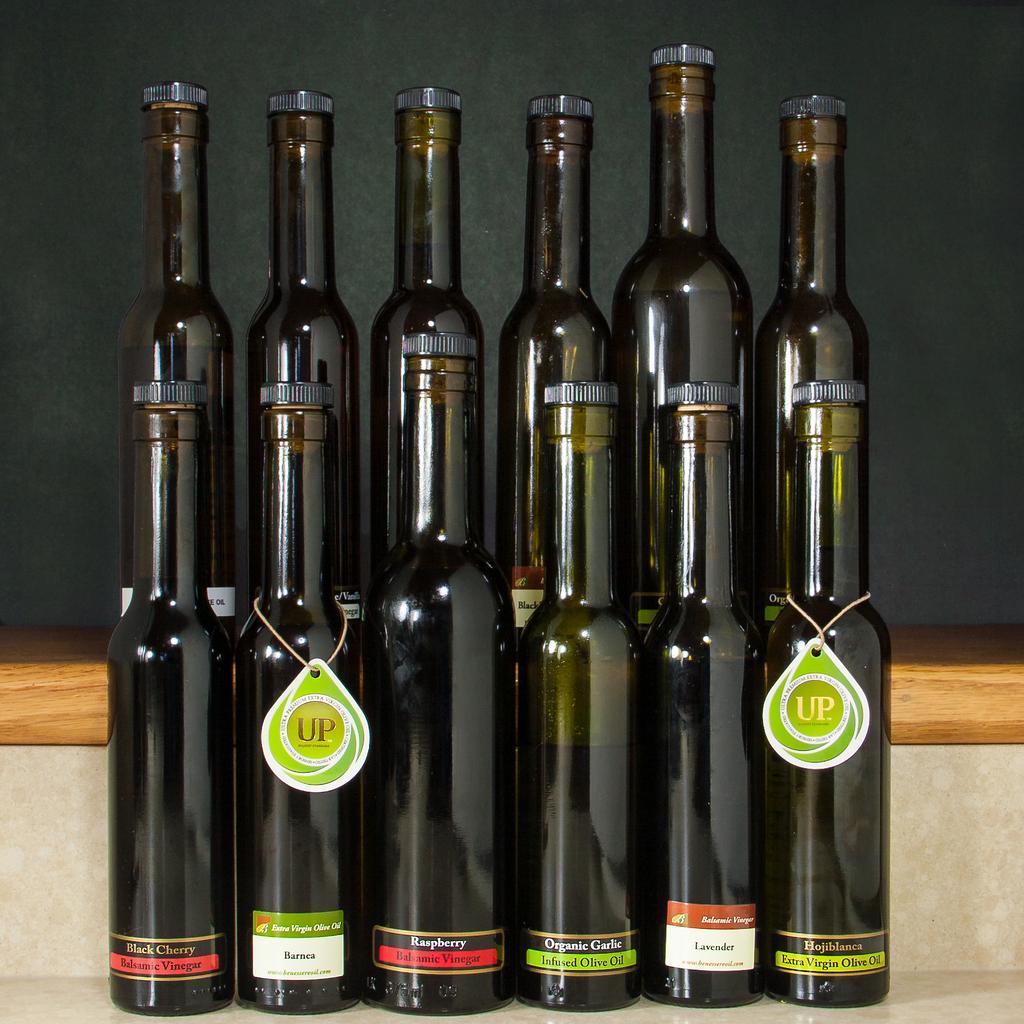In one or two sentences, can you explain what this image depicts? We can able to see bottles in this picture. 